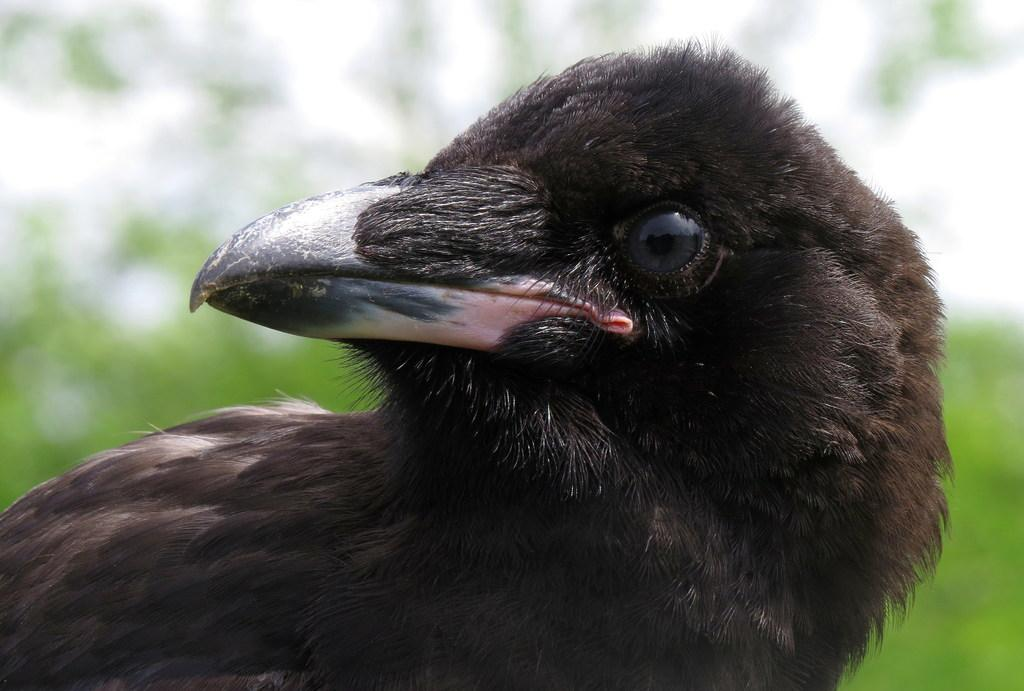What type of animal can be seen in the image? There is a bird in the image. Can you describe the background of the image? The background of the image is blurred. What type of horn can be seen in the image? There is no horn present in the image; it features a bird and a blurred background. How many flowers are visible in the image? There are no flowers visible in the image; it features a bird and a blurred background. 